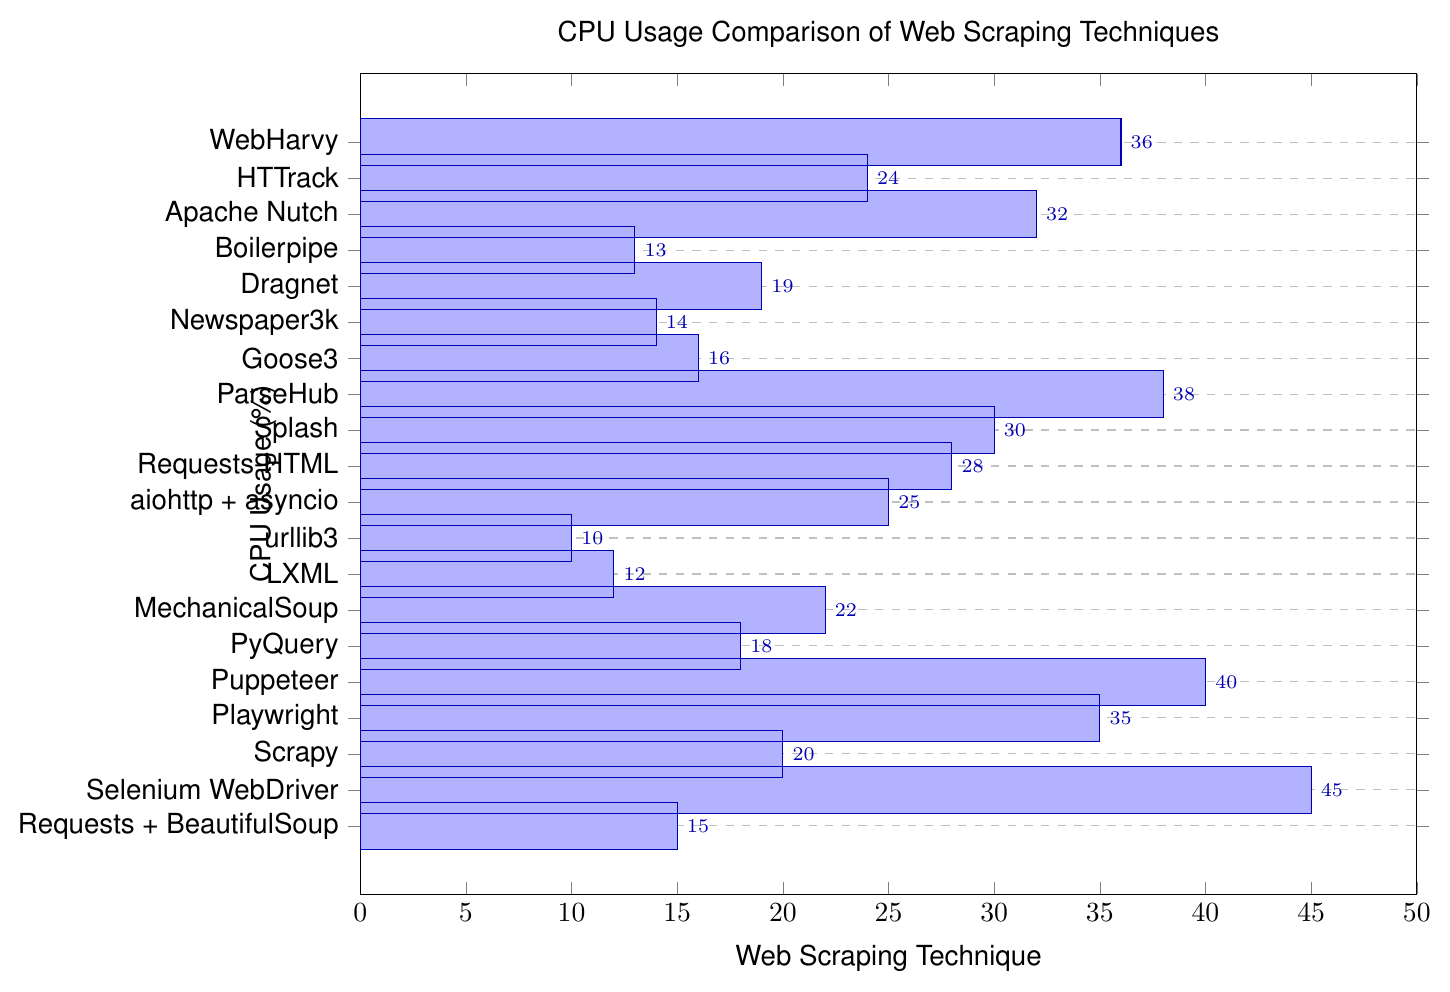what is the lowest CPU usage percentage among the techniques? The lowest CPU usage percentage is determined by finding the smallest value among the data points. According to the provided data, urllib3 has the lowest CPU usage at 10%.
Answer: 10% which techniques have a CPU usage below 20%? Reviewing the bar chart, we identify the techniques with CPU usage percentages lower than 20%. These techniques are urllib3 (10%), LXML (12%), Boilerpipe (13%), Newspaper3k (14%), Requests + BeautifulSoup (15%), Goose3 (16%), and PyQuery (18%).
Answer: urllib3, LXML, Boilerpipe, Newspaper3k, Requests + BeautifulSoup, Goose3, PyQuery which technique has the highest CPU usage and what is its value? Scanning the bar chart, we search for the bar with the greatest length. Selenium WebDriver stands out as having the highest CPU usage at 45%.
Answer: Selenium WebDriver, 45% what is the average CPU usage percentage for Selenium WebDriver, Playwright, and Scrapy? To determine the average, we first sum the CPU usage percentages of Selenium WebDriver (45%), Playwright (35%), and Scrapy (20%): (45 + 35 + 20) = 100. Then, we divide this sum by the number of techniques, which is 3: 100 / 3 = 33.33%.
Answer: 33.33% how does the CPU usage of Requests + BeautifulSoup compare to Apache Nutch? Comparing the CPU usage percentages of Requests + BeautifulSoup (15%) and Apache Nutch (32%) reveals that Apache Nutch has a higher CPU usage than Requests + BeautifulSoup.
Answer: Apache Nutch > Requests + BeautifulSoup what are the total CPU usage values for techniques with CPU usage above 25%? Summing the CPU usage of techniques above 25%: Selenium WebDriver (45%), Playwright (35%), Puppeteer (40%), ParseHub (38%), WebHarvy (36%), Requests-HTML (28%), Splash (30%), and aiohttp + asyncio (25%), we get (45 + 35 + 40 + 38 + 36 + 28 + 30 + 25) = 277%.
Answer: 277% which technique with a blue-colored bar has the highest CPU usage? Observing the chart, we identify the blue-colored bars and compare their CPU usage. Selenium WebDriver (45%) has the highest CPU usage among the blue-colored bars.
Answer: Selenium WebDriver what is the median CPU usage percentage for all the techniques? Sorting the CPU usage percentages in ascending order: 10, 12, 13, 14, 15, 16, 18, 19, 20, 22, 24, 25, 28, 30, 32, 35, 36, 38, 40, 45. The median is the average of the 10th and 11th numbers: (22 + 24) / 2 = 23%.
Answer: 23% compare the cumulative CPU usage of MechanicalSoup, PyQuery, and Boilerpipe to Apache Nutch. Summing MechanicalSoup (22%), PyQuery (18%), and Boilerpipe (13%) gives (22 + 18 + 13) = 53%. Apache Nutch alone is 32%. Therefore, the cumulative CPU usage of MechanicalSoup, PyQuery, and Boilerpipe is significantly higher than Apache Nutch.
Answer: 53% > 32% which techniques fall within the middle range of CPU usage from 20% to 30% inclusive? Based on the chart, the techniques with CPU usages within the 20% to 30% range are Scrapy (20%), MechanicalSoup (22%), HTTrack (24%), aiohttp + asyncio (25%), Requests-HTML (28%), and Splash (30%).
Answer: Scrapy, MechanicalSoup, HTTrack, aiohttp + asyncio, Requests-HTML, Splash 